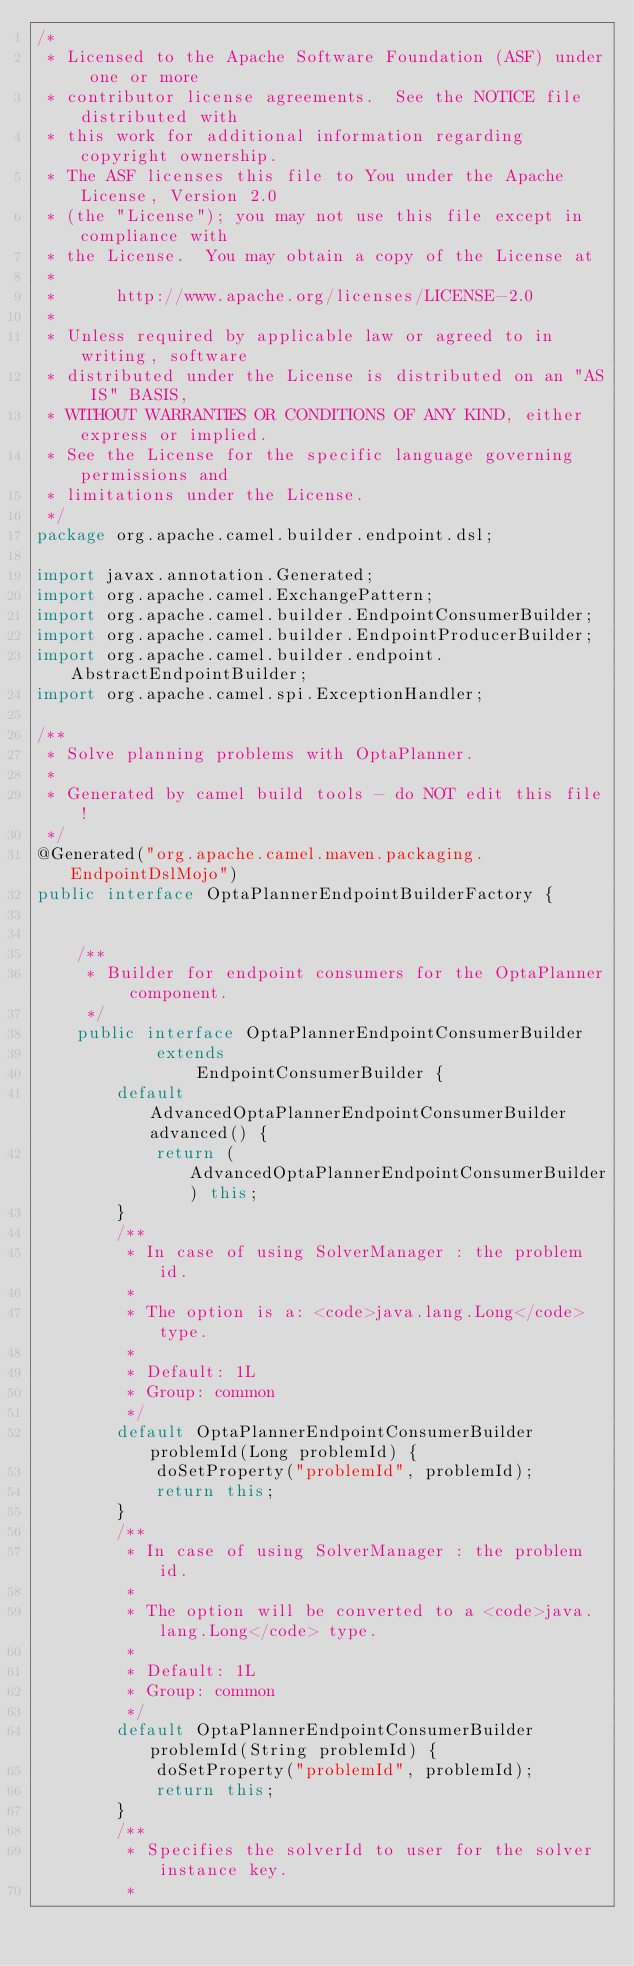Convert code to text. <code><loc_0><loc_0><loc_500><loc_500><_Java_>/*
 * Licensed to the Apache Software Foundation (ASF) under one or more
 * contributor license agreements.  See the NOTICE file distributed with
 * this work for additional information regarding copyright ownership.
 * The ASF licenses this file to You under the Apache License, Version 2.0
 * (the "License"); you may not use this file except in compliance with
 * the License.  You may obtain a copy of the License at
 *
 *      http://www.apache.org/licenses/LICENSE-2.0
 *
 * Unless required by applicable law or agreed to in writing, software
 * distributed under the License is distributed on an "AS IS" BASIS,
 * WITHOUT WARRANTIES OR CONDITIONS OF ANY KIND, either express or implied.
 * See the License for the specific language governing permissions and
 * limitations under the License.
 */
package org.apache.camel.builder.endpoint.dsl;

import javax.annotation.Generated;
import org.apache.camel.ExchangePattern;
import org.apache.camel.builder.EndpointConsumerBuilder;
import org.apache.camel.builder.EndpointProducerBuilder;
import org.apache.camel.builder.endpoint.AbstractEndpointBuilder;
import org.apache.camel.spi.ExceptionHandler;

/**
 * Solve planning problems with OptaPlanner.
 * 
 * Generated by camel build tools - do NOT edit this file!
 */
@Generated("org.apache.camel.maven.packaging.EndpointDslMojo")
public interface OptaPlannerEndpointBuilderFactory {


    /**
     * Builder for endpoint consumers for the OptaPlanner component.
     */
    public interface OptaPlannerEndpointConsumerBuilder
            extends
                EndpointConsumerBuilder {
        default AdvancedOptaPlannerEndpointConsumerBuilder advanced() {
            return (AdvancedOptaPlannerEndpointConsumerBuilder) this;
        }
        /**
         * In case of using SolverManager : the problem id.
         * 
         * The option is a: <code>java.lang.Long</code> type.
         * 
         * Default: 1L
         * Group: common
         */
        default OptaPlannerEndpointConsumerBuilder problemId(Long problemId) {
            doSetProperty("problemId", problemId);
            return this;
        }
        /**
         * In case of using SolverManager : the problem id.
         * 
         * The option will be converted to a <code>java.lang.Long</code> type.
         * 
         * Default: 1L
         * Group: common
         */
        default OptaPlannerEndpointConsumerBuilder problemId(String problemId) {
            doSetProperty("problemId", problemId);
            return this;
        }
        /**
         * Specifies the solverId to user for the solver instance key.
         * </code> 